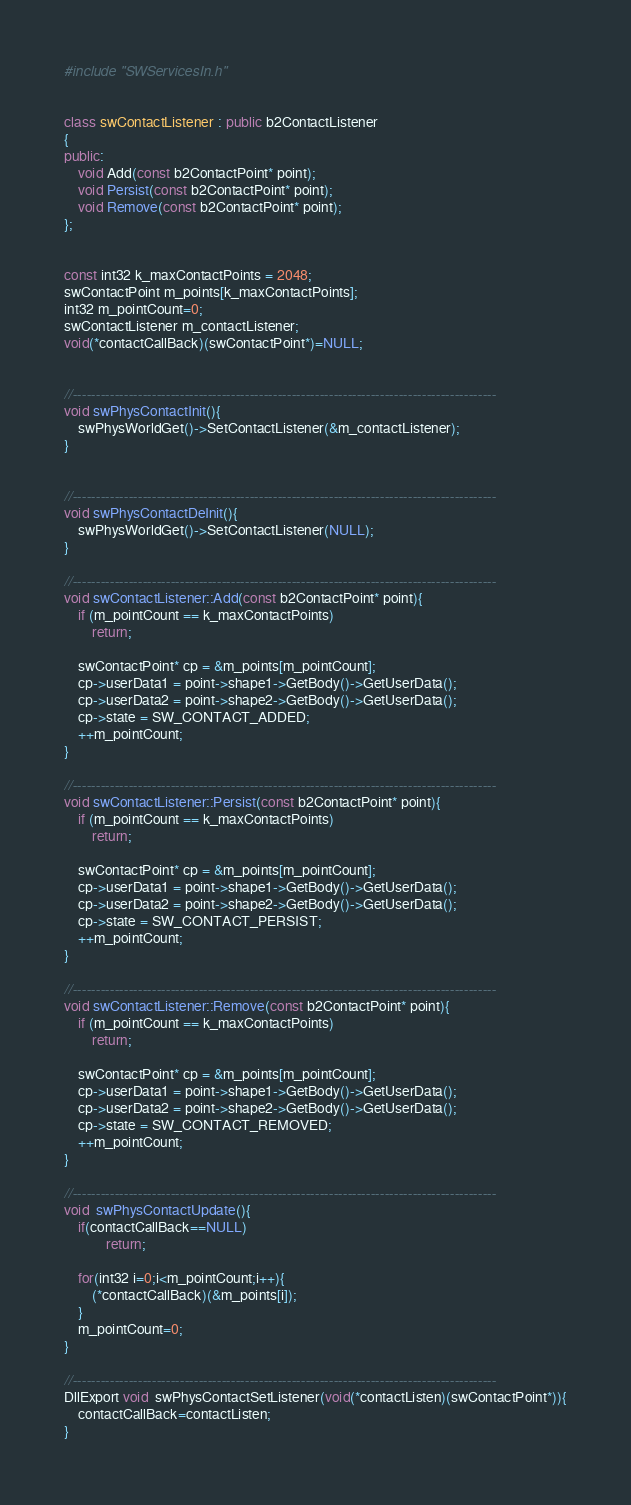Convert code to text. <code><loc_0><loc_0><loc_500><loc_500><_C++_>#include "SWServicesIn.h"


class swContactListener : public b2ContactListener
{
public:
	void Add(const b2ContactPoint* point);
	void Persist(const b2ContactPoint* point);
	void Remove(const b2ContactPoint* point);
};


const int32 k_maxContactPoints = 2048;
swContactPoint m_points[k_maxContactPoints];
int32 m_pointCount=0;
swContactListener m_contactListener;
void(*contactCallBack)(swContactPoint*)=NULL;


//-------------------------------------------------------------------------------------------
void swPhysContactInit(){
	swPhysWorldGet()->SetContactListener(&m_contactListener);
}


//-------------------------------------------------------------------------------------------
void swPhysContactDeInit(){
	swPhysWorldGet()->SetContactListener(NULL);
}

//-------------------------------------------------------------------------------------------
void swContactListener::Add(const b2ContactPoint* point){
	if (m_pointCount == k_maxContactPoints)
		return;

	swContactPoint* cp = &m_points[m_pointCount];
	cp->userData1 = point->shape1->GetBody()->GetUserData();
	cp->userData2 = point->shape2->GetBody()->GetUserData();
	cp->state = SW_CONTACT_ADDED;
	++m_pointCount;
}

//-------------------------------------------------------------------------------------------
void swContactListener::Persist(const b2ContactPoint* point){
	if (m_pointCount == k_maxContactPoints)
		return;

	swContactPoint* cp = &m_points[m_pointCount];
	cp->userData1 = point->shape1->GetBody()->GetUserData();
	cp->userData2 = point->shape2->GetBody()->GetUserData();
	cp->state = SW_CONTACT_PERSIST;
	++m_pointCount;
}

//-------------------------------------------------------------------------------------------
void swContactListener::Remove(const b2ContactPoint* point){
	if (m_pointCount == k_maxContactPoints)
		return;
	
	swContactPoint* cp = &m_points[m_pointCount];
	cp->userData1 = point->shape1->GetBody()->GetUserData();
	cp->userData2 = point->shape2->GetBody()->GetUserData();
	cp->state = SW_CONTACT_REMOVED;
	++m_pointCount;
}

//-------------------------------------------------------------------------------------------
void  swPhysContactUpdate(){
	if(contactCallBack==NULL)
			return;

	for(int32 i=0;i<m_pointCount;i++){
		(*contactCallBack)(&m_points[i]);
	}
	m_pointCount=0;
}

//-------------------------------------------------------------------------------------------
DllExport void  swPhysContactSetListener(void(*contactListen)(swContactPoint*)){
	contactCallBack=contactListen;
}
</code> 